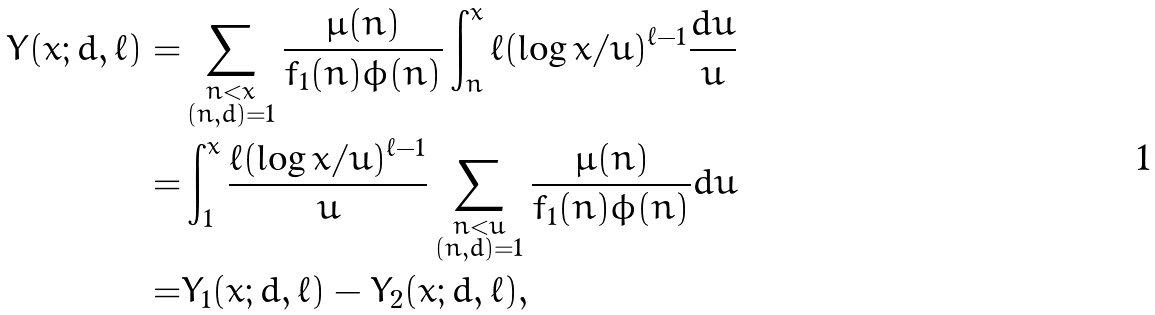Convert formula to latex. <formula><loc_0><loc_0><loc_500><loc_500>Y ( x ; d , \ell ) = & \sum _ { \substack { n < x \\ ( n , d ) = 1 } } \frac { \mu ( n ) } { f _ { 1 } ( n ) \phi ( n ) } \int _ { n } ^ { x } \ell ( \log x / u ) ^ { \ell - 1 } \frac { d u } { u } \\ = & \int _ { 1 } ^ { x } \frac { \ell ( \log x / u ) ^ { \ell - 1 } } { u } \sum _ { \substack { n < u \\ ( n , d ) = 1 } } \frac { \mu ( n ) } { f _ { 1 } ( n ) \phi ( n ) } d u \\ = & Y _ { 1 } ( x ; d , \ell ) - Y _ { 2 } ( x ; d , \ell ) ,</formula> 